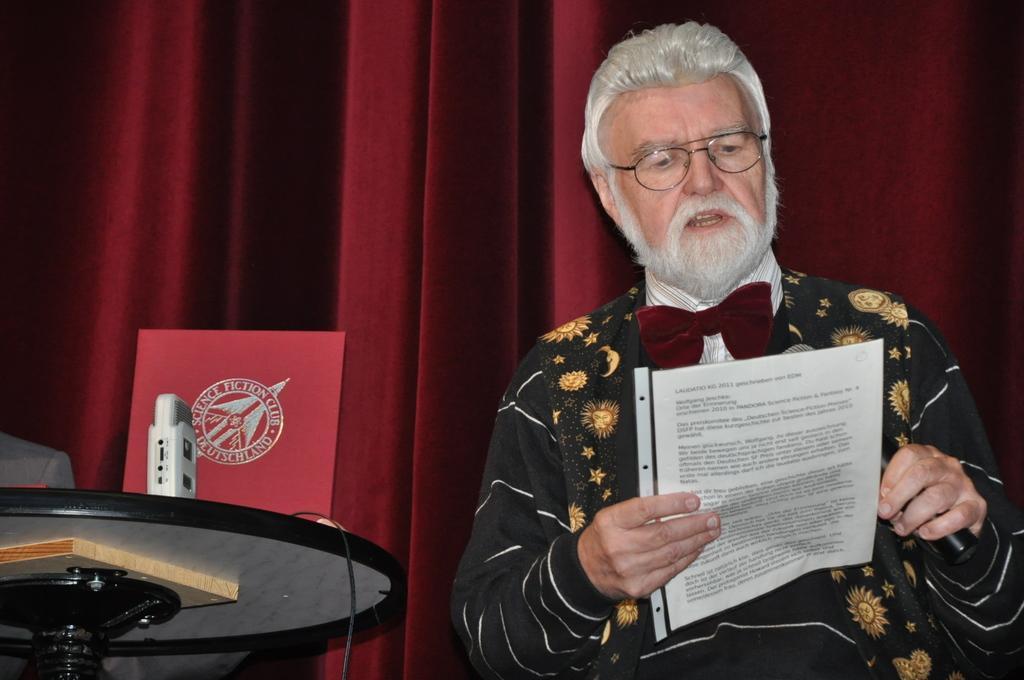Can you describe this image briefly? In this image I can see a person standing on the right, he is holding a microphone and a paper. There is a stand on the left. There are curtains at the back. 